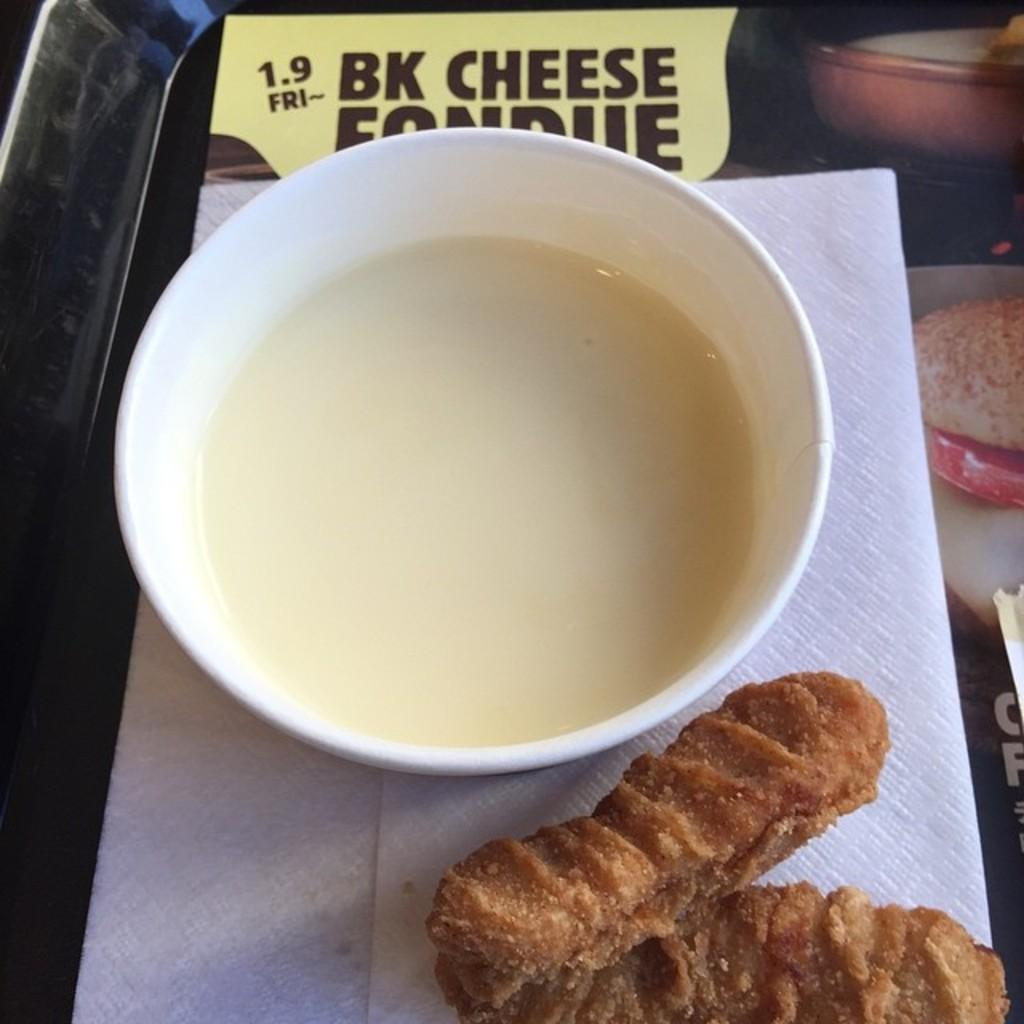What is contained in the disposable glass in the image? There is a drink in a disposable glass in the image. What is the food resting on in the image? The food is on a tissue in the image. What is located at the bottom of the image? There is a tray at the bottom of the image. What can be seen on the tray in the image? There is text on the tray. How does the size of the food on the tissue compare to the size of the drink in the disposable glass? The size of the food on the tissue and the drink in the disposable glass cannot be compared in the image, as there is no information provided about their relative sizes. 